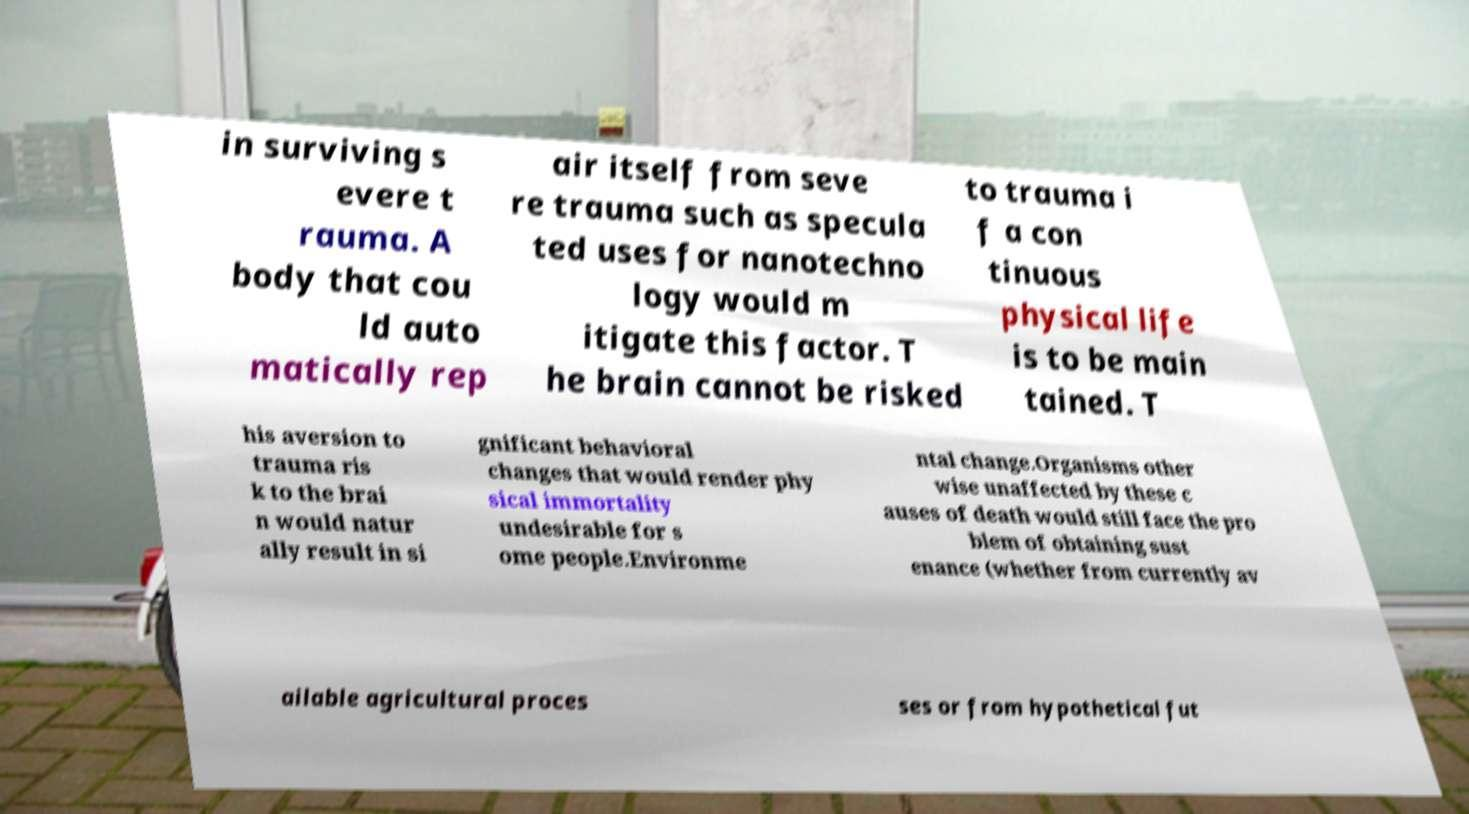Can you accurately transcribe the text from the provided image for me? in surviving s evere t rauma. A body that cou ld auto matically rep air itself from seve re trauma such as specula ted uses for nanotechno logy would m itigate this factor. T he brain cannot be risked to trauma i f a con tinuous physical life is to be main tained. T his aversion to trauma ris k to the brai n would natur ally result in si gnificant behavioral changes that would render phy sical immortality undesirable for s ome people.Environme ntal change.Organisms other wise unaffected by these c auses of death would still face the pro blem of obtaining sust enance (whether from currently av ailable agricultural proces ses or from hypothetical fut 